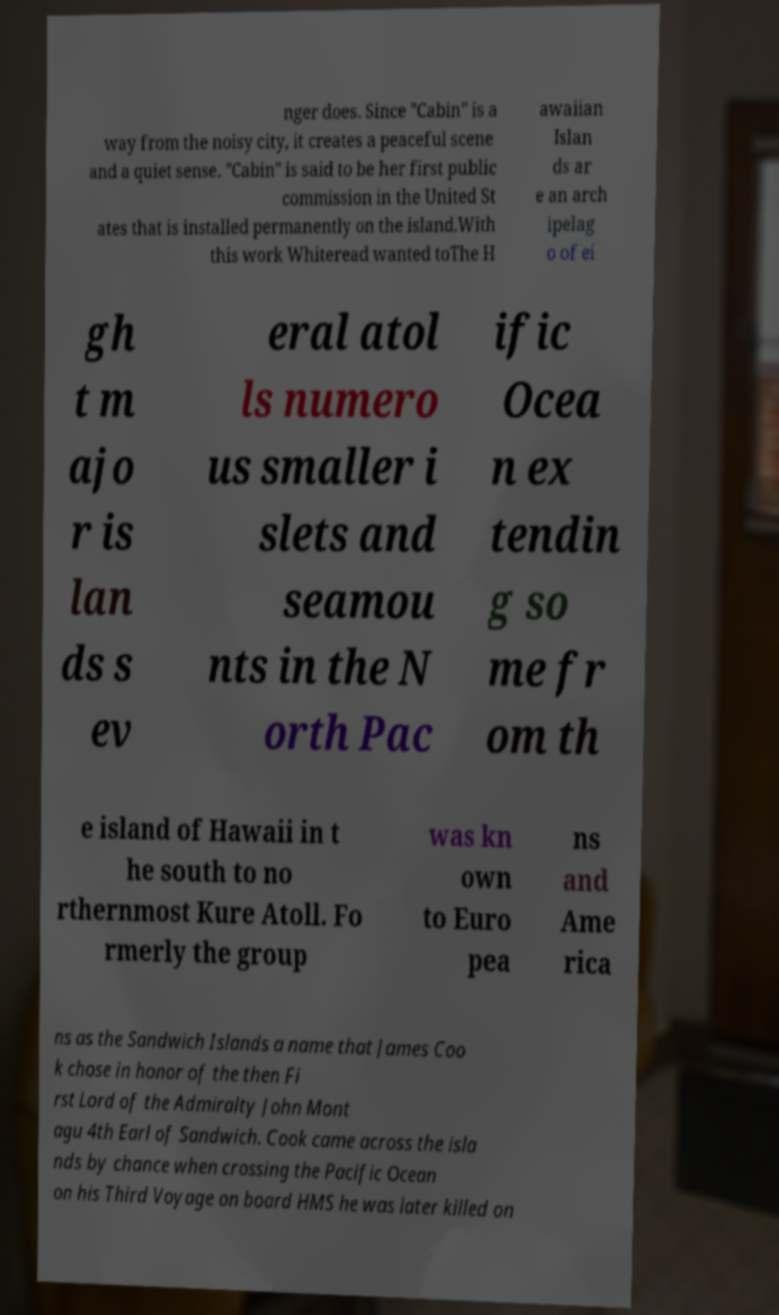For documentation purposes, I need the text within this image transcribed. Could you provide that? nger does. Since "Cabin" is a way from the noisy city, it creates a peaceful scene and a quiet sense. "Cabin" is said to be her first public commission in the United St ates that is installed permanently on the island.With this work Whiteread wanted toThe H awaiian Islan ds ar e an arch ipelag o of ei gh t m ajo r is lan ds s ev eral atol ls numero us smaller i slets and seamou nts in the N orth Pac ific Ocea n ex tendin g so me fr om th e island of Hawaii in t he south to no rthernmost Kure Atoll. Fo rmerly the group was kn own to Euro pea ns and Ame rica ns as the Sandwich Islands a name that James Coo k chose in honor of the then Fi rst Lord of the Admiralty John Mont agu 4th Earl of Sandwich. Cook came across the isla nds by chance when crossing the Pacific Ocean on his Third Voyage on board HMS he was later killed on 